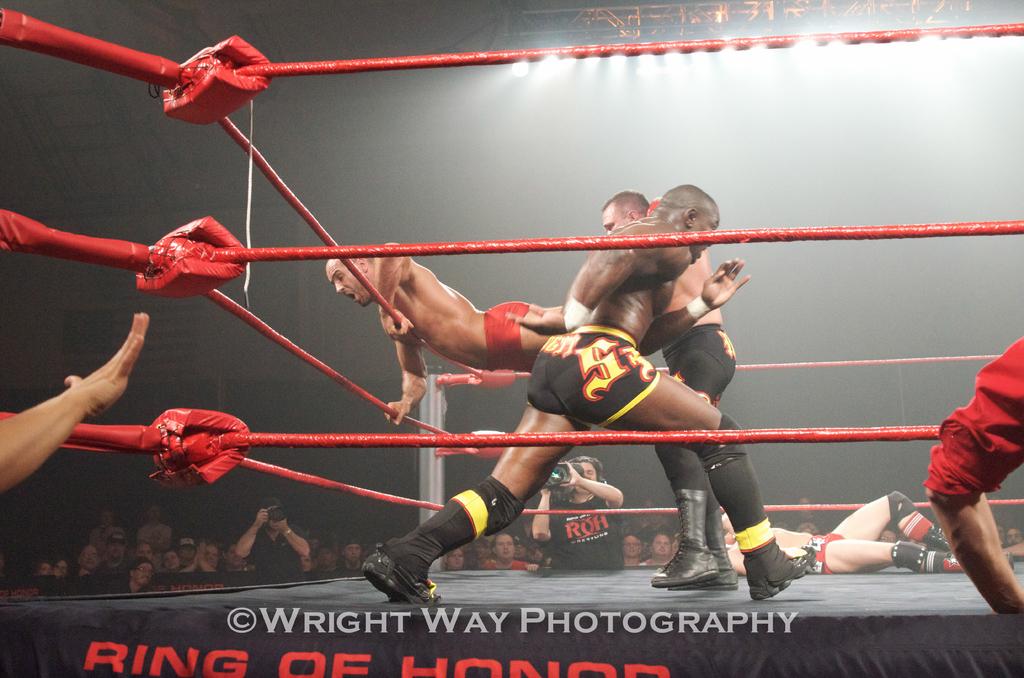Who owns this picture?
Give a very brief answer. Wright way photography. 